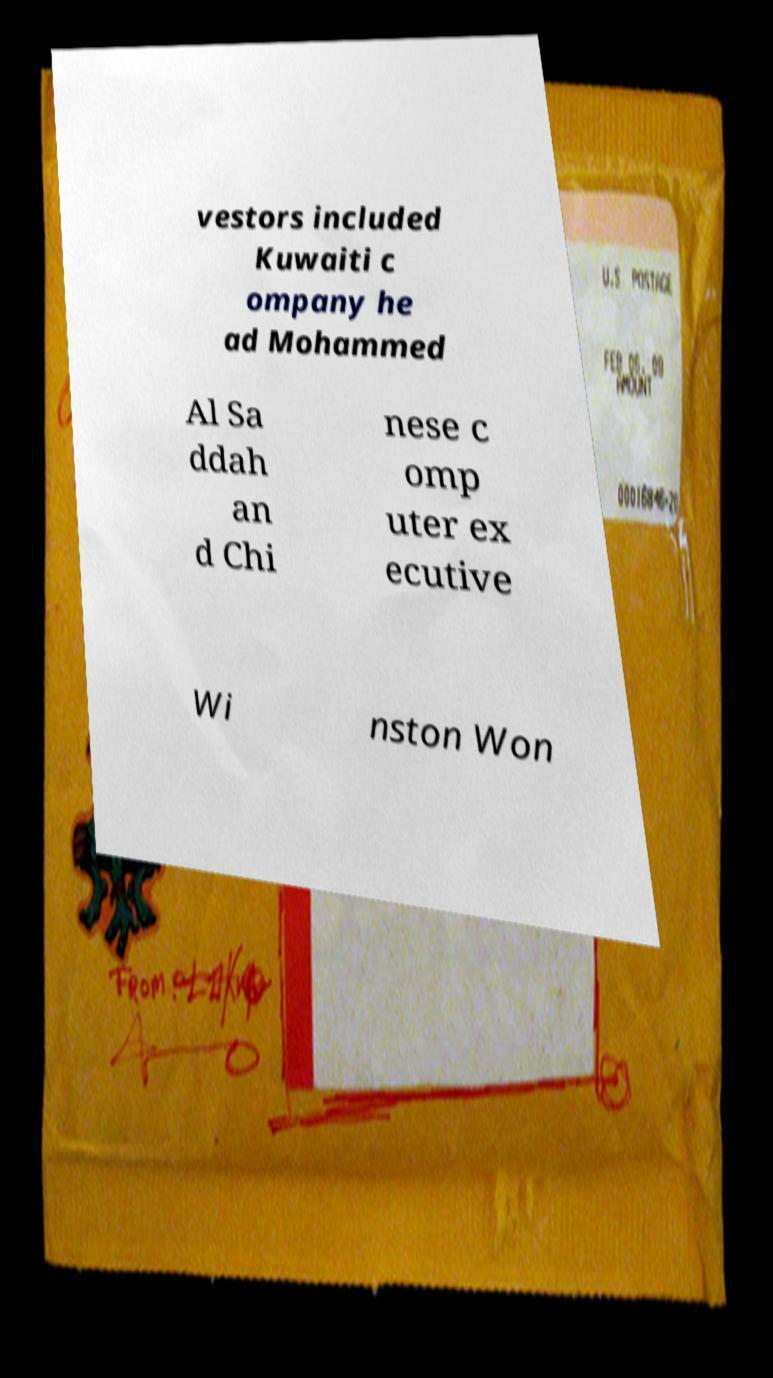I need the written content from this picture converted into text. Can you do that? vestors included Kuwaiti c ompany he ad Mohammed Al Sa ddah an d Chi nese c omp uter ex ecutive Wi nston Won 